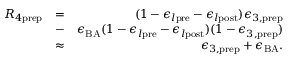<formula> <loc_0><loc_0><loc_500><loc_500>\begin{array} { r l r } { R _ { 4 p r e p } } & { = } & { ( 1 - \epsilon _ { l p r e } - \epsilon _ { l p o s t } ) \epsilon _ { 3 , p r e p } } \\ & { - } & { \epsilon _ { B A } ( 1 - \epsilon _ { l p r e } - \epsilon _ { l p o s t } ) ( 1 - \epsilon _ { 3 , p r e p } ) } \\ & { \approx } & { \epsilon _ { 3 , p r e p } + \epsilon _ { B A } . } \end{array}</formula> 